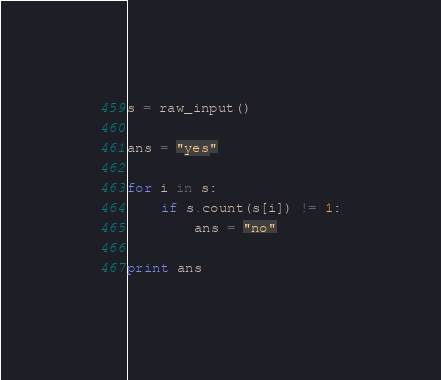Convert code to text. <code><loc_0><loc_0><loc_500><loc_500><_Python_>s = raw_input()

ans = "yes"

for i in s:
    if s.count(s[i]) != 1:
        ans = "no"

print ans</code> 